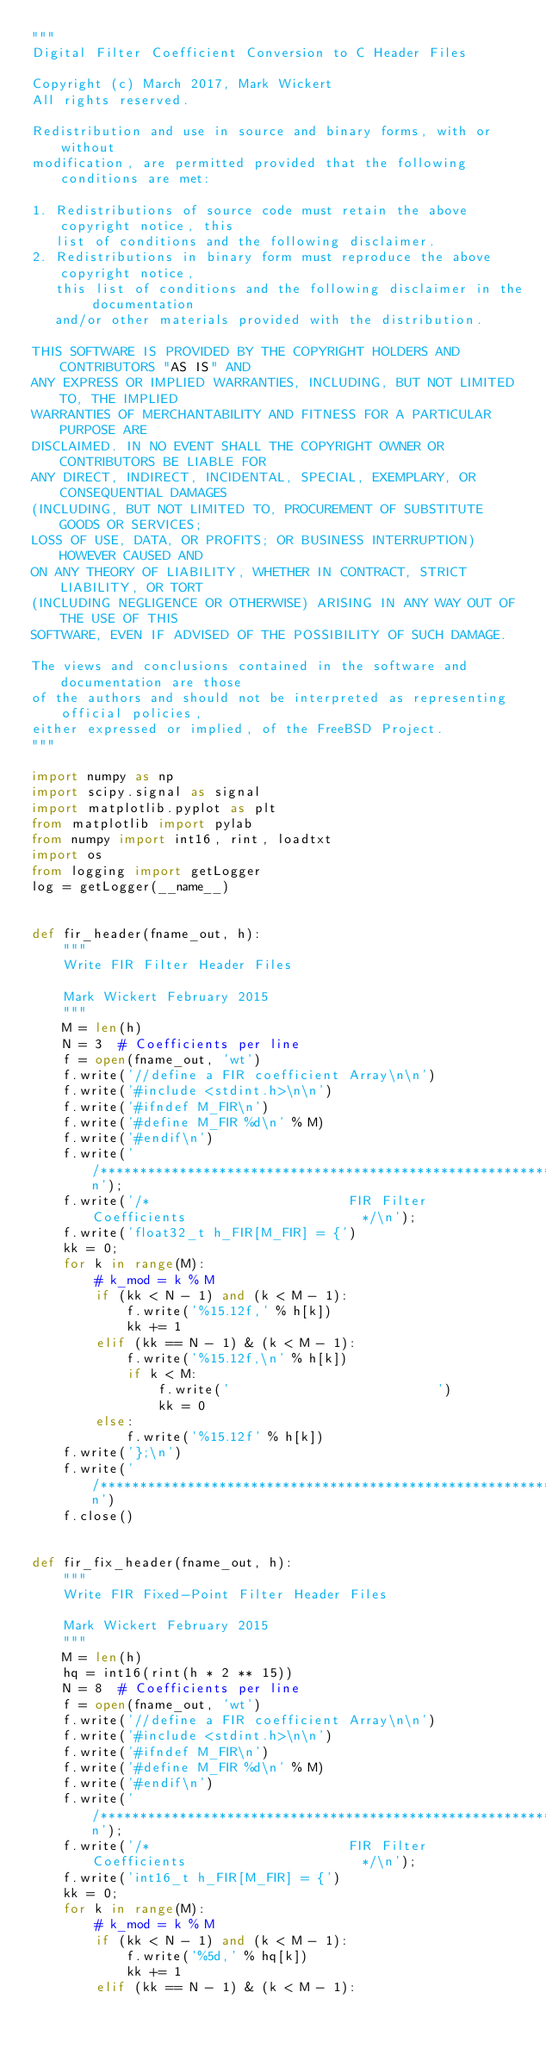<code> <loc_0><loc_0><loc_500><loc_500><_Python_>"""
Digital Filter Coefficient Conversion to C Header Files

Copyright (c) March 2017, Mark Wickert
All rights reserved.

Redistribution and use in source and binary forms, with or without
modification, are permitted provided that the following conditions are met:

1. Redistributions of source code must retain the above copyright notice, this
   list of conditions and the following disclaimer.
2. Redistributions in binary form must reproduce the above copyright notice,
   this list of conditions and the following disclaimer in the documentation
   and/or other materials provided with the distribution.

THIS SOFTWARE IS PROVIDED BY THE COPYRIGHT HOLDERS AND CONTRIBUTORS "AS IS" AND
ANY EXPRESS OR IMPLIED WARRANTIES, INCLUDING, BUT NOT LIMITED TO, THE IMPLIED
WARRANTIES OF MERCHANTABILITY AND FITNESS FOR A PARTICULAR PURPOSE ARE
DISCLAIMED. IN NO EVENT SHALL THE COPYRIGHT OWNER OR CONTRIBUTORS BE LIABLE FOR
ANY DIRECT, INDIRECT, INCIDENTAL, SPECIAL, EXEMPLARY, OR CONSEQUENTIAL DAMAGES
(INCLUDING, BUT NOT LIMITED TO, PROCUREMENT OF SUBSTITUTE GOODS OR SERVICES;
LOSS OF USE, DATA, OR PROFITS; OR BUSINESS INTERRUPTION) HOWEVER CAUSED AND
ON ANY THEORY OF LIABILITY, WHETHER IN CONTRACT, STRICT LIABILITY, OR TORT
(INCLUDING NEGLIGENCE OR OTHERWISE) ARISING IN ANY WAY OUT OF THE USE OF THIS
SOFTWARE, EVEN IF ADVISED OF THE POSSIBILITY OF SUCH DAMAGE.

The views and conclusions contained in the software and documentation are those
of the authors and should not be interpreted as representing official policies,
either expressed or implied, of the FreeBSD Project.
"""

import numpy as np
import scipy.signal as signal
import matplotlib.pyplot as plt
from matplotlib import pylab
from numpy import int16, rint, loadtxt
import os
from logging import getLogger
log = getLogger(__name__)


def fir_header(fname_out, h):
    """
    Write FIR Filter Header Files

    Mark Wickert February 2015
    """
    M = len(h)
    N = 3  # Coefficients per line
    f = open(fname_out, 'wt')
    f.write('//define a FIR coefficient Array\n\n')
    f.write('#include <stdint.h>\n\n')
    f.write('#ifndef M_FIR\n')
    f.write('#define M_FIR %d\n' % M)
    f.write('#endif\n')
    f.write('/************************************************************************/\n');
    f.write('/*                         FIR Filter Coefficients                      */\n');
    f.write('float32_t h_FIR[M_FIR] = {')
    kk = 0;
    for k in range(M):
        # k_mod = k % M
        if (kk < N - 1) and (k < M - 1):
            f.write('%15.12f,' % h[k])
            kk += 1
        elif (kk == N - 1) & (k < M - 1):
            f.write('%15.12f,\n' % h[k])
            if k < M:
                f.write('                          ')
                kk = 0
        else:
            f.write('%15.12f' % h[k])
    f.write('};\n')
    f.write('/************************************************************************/\n')
    f.close()


def fir_fix_header(fname_out, h):
    """
    Write FIR Fixed-Point Filter Header Files 
    
    Mark Wickert February 2015
    """
    M = len(h)
    hq = int16(rint(h * 2 ** 15))
    N = 8  # Coefficients per line
    f = open(fname_out, 'wt')
    f.write('//define a FIR coefficient Array\n\n')
    f.write('#include <stdint.h>\n\n')
    f.write('#ifndef M_FIR\n')
    f.write('#define M_FIR %d\n' % M)
    f.write('#endif\n')
    f.write('/************************************************************************/\n');
    f.write('/*                         FIR Filter Coefficients                      */\n');
    f.write('int16_t h_FIR[M_FIR] = {')
    kk = 0;
    for k in range(M):
        # k_mod = k % M
        if (kk < N - 1) and (k < M - 1):
            f.write('%5d,' % hq[k])
            kk += 1
        elif (kk == N - 1) & (k < M - 1):</code> 